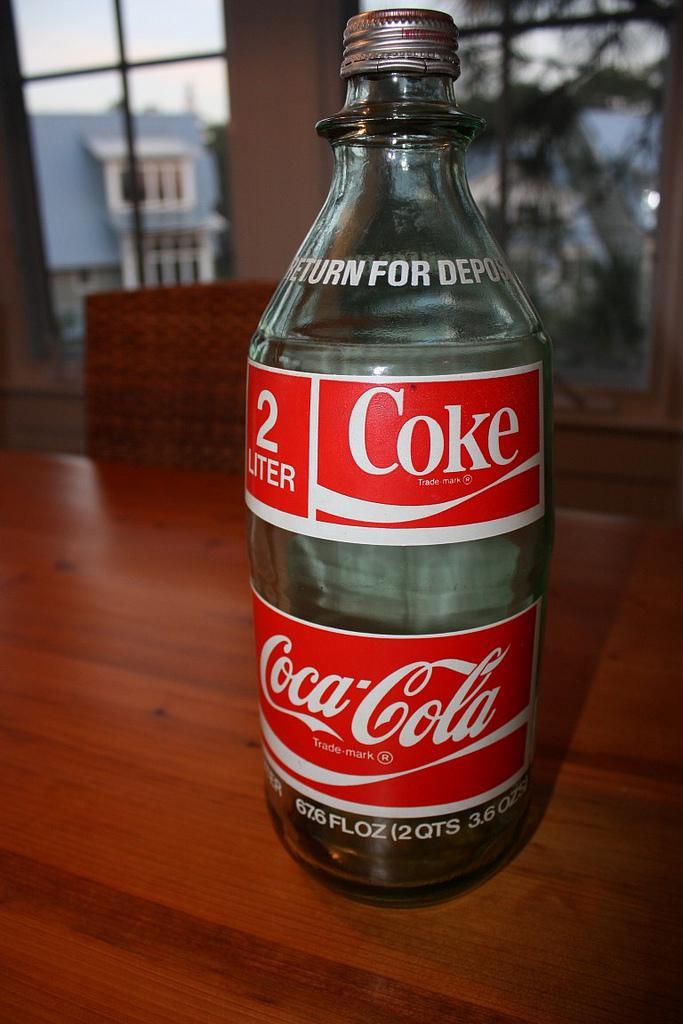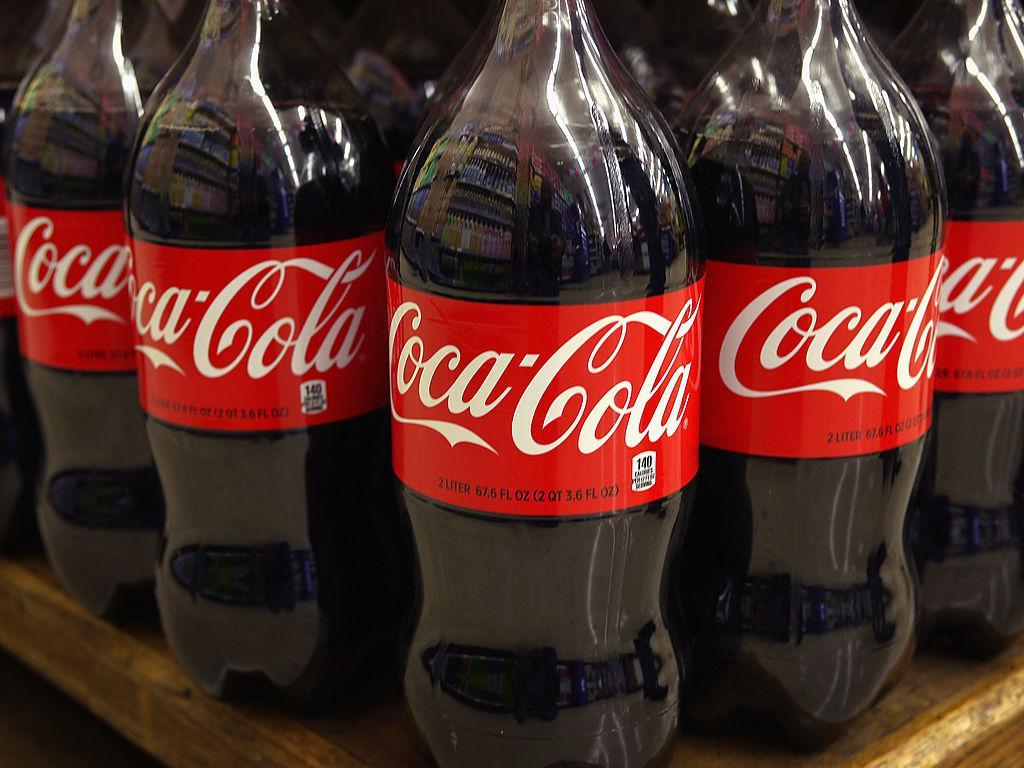The first image is the image on the left, the second image is the image on the right. Considering the images on both sides, is "There are exactly three bottles of soda." valid? Answer yes or no. No. The first image is the image on the left, the second image is the image on the right. Given the left and right images, does the statement "The left image features one full bottle of cola with a red wrapper standing upright, and the right image contains two full bottles of cola with red wrappers positioned side-by-side." hold true? Answer yes or no. No. 